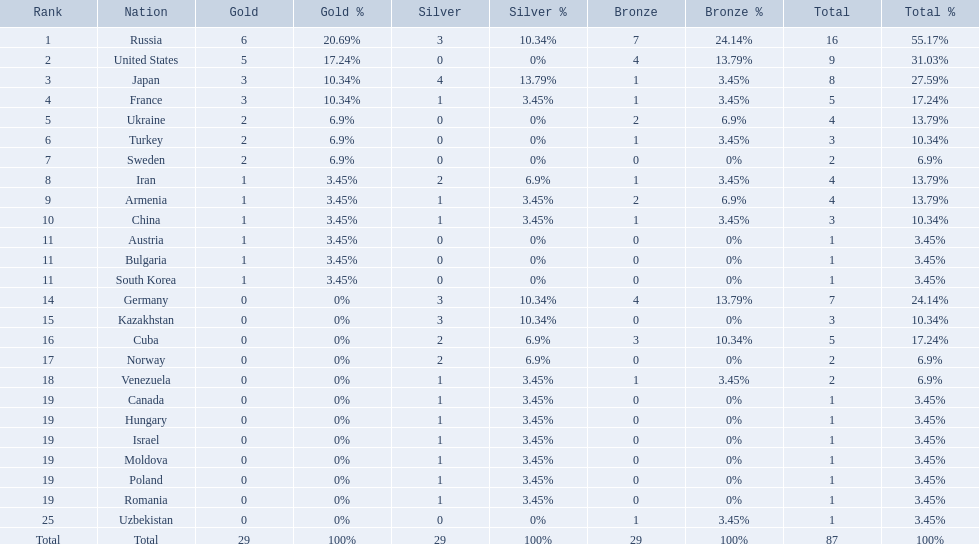What nations have one gold medal? Iran, Armenia, China, Austria, Bulgaria, South Korea. Of these, which nations have zero silver medals? Austria, Bulgaria, South Korea. Of these, which nations also have zero bronze medals? Austria. 